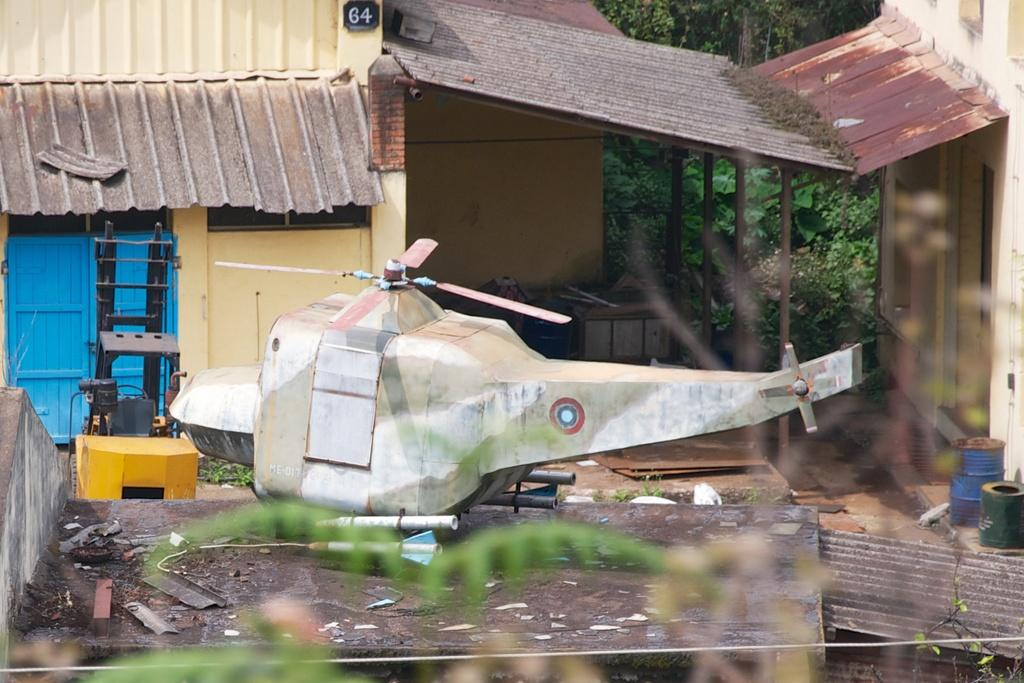What type of structures can be seen in the image? There are buildings in the image. What mode of transportation is present in the image? There is a helicopter in the image. What are the tall, thin objects in the image? There are poles in the image. What can be used for entering or exiting the buildings? There are doors in the image. What type of vegetation is visible in the image? There are trees in the image. What musical instruments can be seen in the image? There are drums in the image. What other objects are present on the ground in the image? There are other objects on the ground in the image. How does the temper of the helicopter affect its performance in the image? There is no indication of the helicopter's temper in the image, as it is an inanimate object. What type of system is responsible for the functioning of the trees in the image? Trees are living organisms and do not rely on a specific system for functioning in the image. 